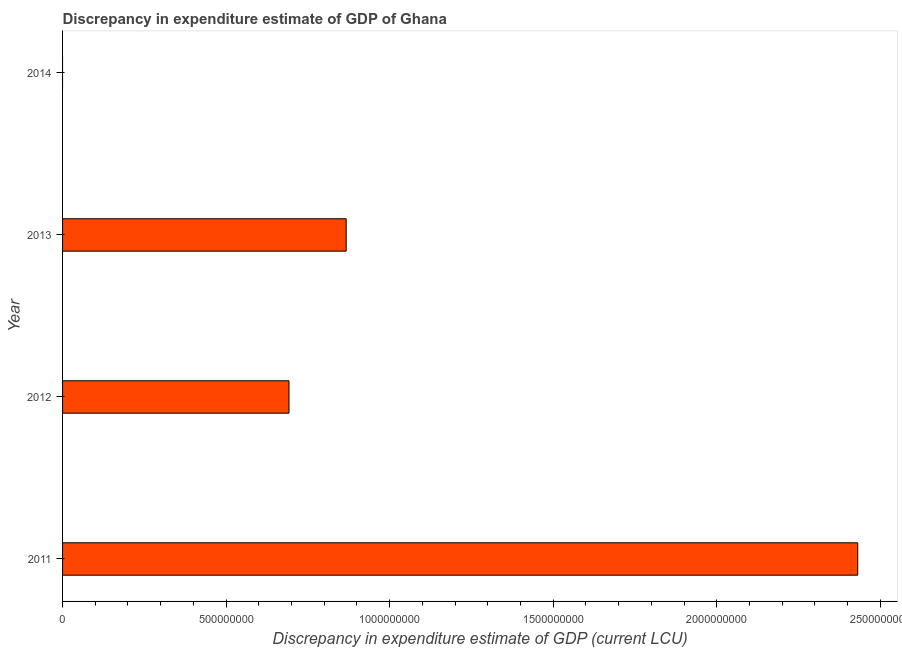Does the graph contain any zero values?
Your answer should be very brief. Yes. Does the graph contain grids?
Provide a succinct answer. No. What is the title of the graph?
Your answer should be very brief. Discrepancy in expenditure estimate of GDP of Ghana. What is the label or title of the X-axis?
Give a very brief answer. Discrepancy in expenditure estimate of GDP (current LCU). What is the label or title of the Y-axis?
Your response must be concise. Year. What is the discrepancy in expenditure estimate of gdp in 2013?
Your answer should be compact. 8.67e+08. Across all years, what is the maximum discrepancy in expenditure estimate of gdp?
Provide a short and direct response. 2.43e+09. In which year was the discrepancy in expenditure estimate of gdp maximum?
Make the answer very short. 2011. What is the sum of the discrepancy in expenditure estimate of gdp?
Provide a succinct answer. 3.99e+09. What is the difference between the discrepancy in expenditure estimate of gdp in 2012 and 2013?
Your answer should be very brief. -1.75e+08. What is the average discrepancy in expenditure estimate of gdp per year?
Your response must be concise. 9.98e+08. What is the median discrepancy in expenditure estimate of gdp?
Give a very brief answer. 7.80e+08. What is the ratio of the discrepancy in expenditure estimate of gdp in 2011 to that in 2012?
Ensure brevity in your answer.  3.51. Is the discrepancy in expenditure estimate of gdp in 2011 less than that in 2012?
Provide a succinct answer. No. What is the difference between the highest and the second highest discrepancy in expenditure estimate of gdp?
Keep it short and to the point. 1.56e+09. What is the difference between the highest and the lowest discrepancy in expenditure estimate of gdp?
Provide a short and direct response. 2.43e+09. In how many years, is the discrepancy in expenditure estimate of gdp greater than the average discrepancy in expenditure estimate of gdp taken over all years?
Provide a short and direct response. 1. What is the difference between two consecutive major ticks on the X-axis?
Offer a very short reply. 5.00e+08. Are the values on the major ticks of X-axis written in scientific E-notation?
Give a very brief answer. No. What is the Discrepancy in expenditure estimate of GDP (current LCU) of 2011?
Offer a terse response. 2.43e+09. What is the Discrepancy in expenditure estimate of GDP (current LCU) of 2012?
Provide a short and direct response. 6.92e+08. What is the Discrepancy in expenditure estimate of GDP (current LCU) in 2013?
Make the answer very short. 8.67e+08. What is the Discrepancy in expenditure estimate of GDP (current LCU) of 2014?
Ensure brevity in your answer.  0. What is the difference between the Discrepancy in expenditure estimate of GDP (current LCU) in 2011 and 2012?
Your answer should be very brief. 1.74e+09. What is the difference between the Discrepancy in expenditure estimate of GDP (current LCU) in 2011 and 2013?
Ensure brevity in your answer.  1.56e+09. What is the difference between the Discrepancy in expenditure estimate of GDP (current LCU) in 2012 and 2013?
Keep it short and to the point. -1.75e+08. What is the ratio of the Discrepancy in expenditure estimate of GDP (current LCU) in 2011 to that in 2012?
Provide a succinct answer. 3.51. What is the ratio of the Discrepancy in expenditure estimate of GDP (current LCU) in 2011 to that in 2013?
Make the answer very short. 2.8. What is the ratio of the Discrepancy in expenditure estimate of GDP (current LCU) in 2012 to that in 2013?
Offer a terse response. 0.8. 